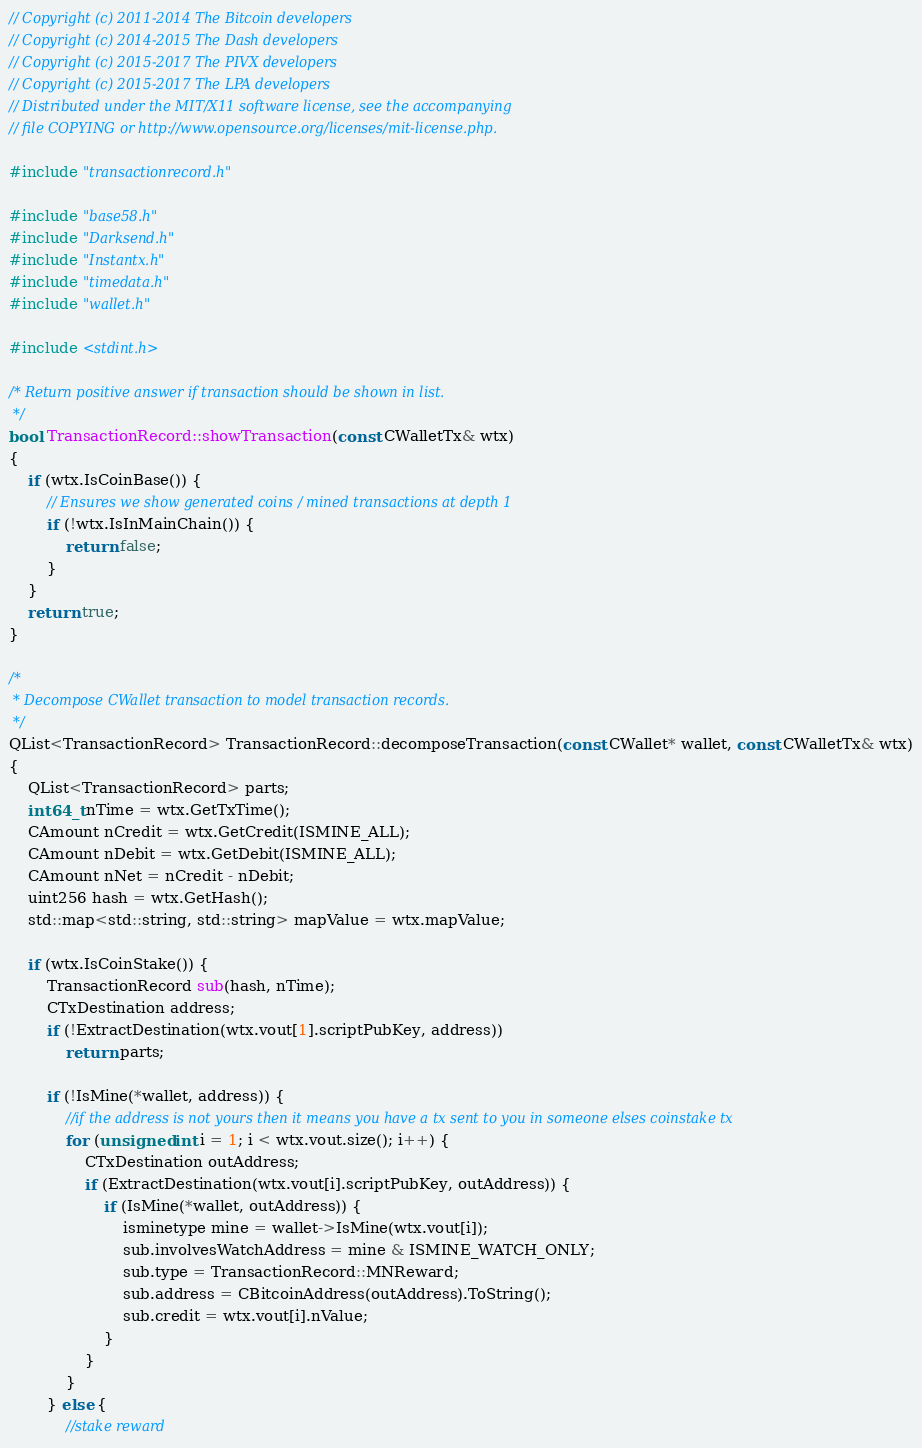Convert code to text. <code><loc_0><loc_0><loc_500><loc_500><_C++_>// Copyright (c) 2011-2014 The Bitcoin developers
// Copyright (c) 2014-2015 The Dash developers
// Copyright (c) 2015-2017 The PIVX developers 
// Copyright (c) 2015-2017 The LPA developers
// Distributed under the MIT/X11 software license, see the accompanying
// file COPYING or http://www.opensource.org/licenses/mit-license.php.

#include "transactionrecord.h"

#include "base58.h"
#include "Darksend.h"
#include "Instantx.h"
#include "timedata.h"
#include "wallet.h"

#include <stdint.h>

/* Return positive answer if transaction should be shown in list.
 */
bool TransactionRecord::showTransaction(const CWalletTx& wtx)
{
    if (wtx.IsCoinBase()) {
        // Ensures we show generated coins / mined transactions at depth 1
        if (!wtx.IsInMainChain()) {
            return false;
        }
    }
    return true;
}

/*
 * Decompose CWallet transaction to model transaction records.
 */
QList<TransactionRecord> TransactionRecord::decomposeTransaction(const CWallet* wallet, const CWalletTx& wtx)
{
    QList<TransactionRecord> parts;
    int64_t nTime = wtx.GetTxTime();
    CAmount nCredit = wtx.GetCredit(ISMINE_ALL);
    CAmount nDebit = wtx.GetDebit(ISMINE_ALL);
    CAmount nNet = nCredit - nDebit;
    uint256 hash = wtx.GetHash();
    std::map<std::string, std::string> mapValue = wtx.mapValue;

    if (wtx.IsCoinStake()) {
        TransactionRecord sub(hash, nTime);
        CTxDestination address;
        if (!ExtractDestination(wtx.vout[1].scriptPubKey, address))
            return parts;

        if (!IsMine(*wallet, address)) {
            //if the address is not yours then it means you have a tx sent to you in someone elses coinstake tx
            for (unsigned int i = 1; i < wtx.vout.size(); i++) {
                CTxDestination outAddress;
                if (ExtractDestination(wtx.vout[i].scriptPubKey, outAddress)) {
                    if (IsMine(*wallet, outAddress)) {
                        isminetype mine = wallet->IsMine(wtx.vout[i]);
                        sub.involvesWatchAddress = mine & ISMINE_WATCH_ONLY;
                        sub.type = TransactionRecord::MNReward;
                        sub.address = CBitcoinAddress(outAddress).ToString();
                        sub.credit = wtx.vout[i].nValue;
                    }
                }
            }
        } else {
            //stake reward</code> 